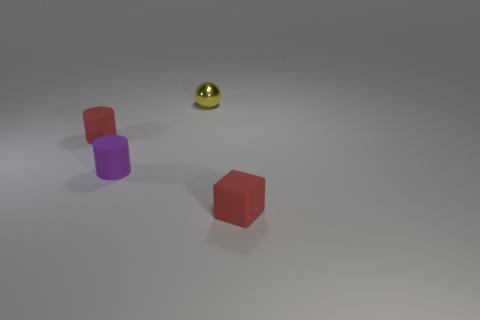Can you tell me what time of day it appears to be in the image based on the lighting? The image seems to have been taken in a controlled indoor environment, perhaps a studio, where the lighting is artificial. This makes it challenging to determine the time of day as there are no natural light indicators such as shadows or a window. 